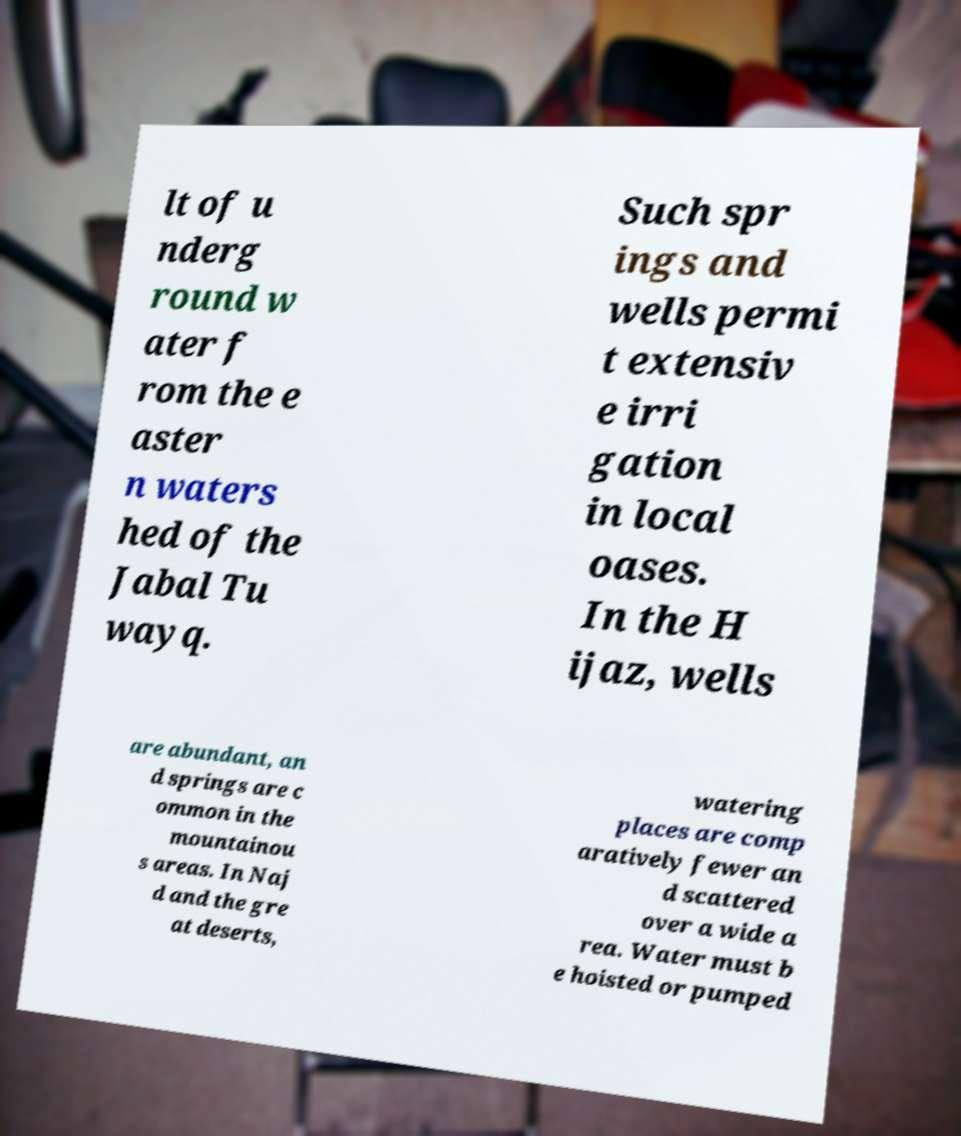Can you read and provide the text displayed in the image?This photo seems to have some interesting text. Can you extract and type it out for me? lt of u nderg round w ater f rom the e aster n waters hed of the Jabal Tu wayq. Such spr ings and wells permi t extensiv e irri gation in local oases. In the H ijaz, wells are abundant, an d springs are c ommon in the mountainou s areas. In Naj d and the gre at deserts, watering places are comp aratively fewer an d scattered over a wide a rea. Water must b e hoisted or pumped 